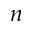Convert formula to latex. <formula><loc_0><loc_0><loc_500><loc_500>n</formula> 